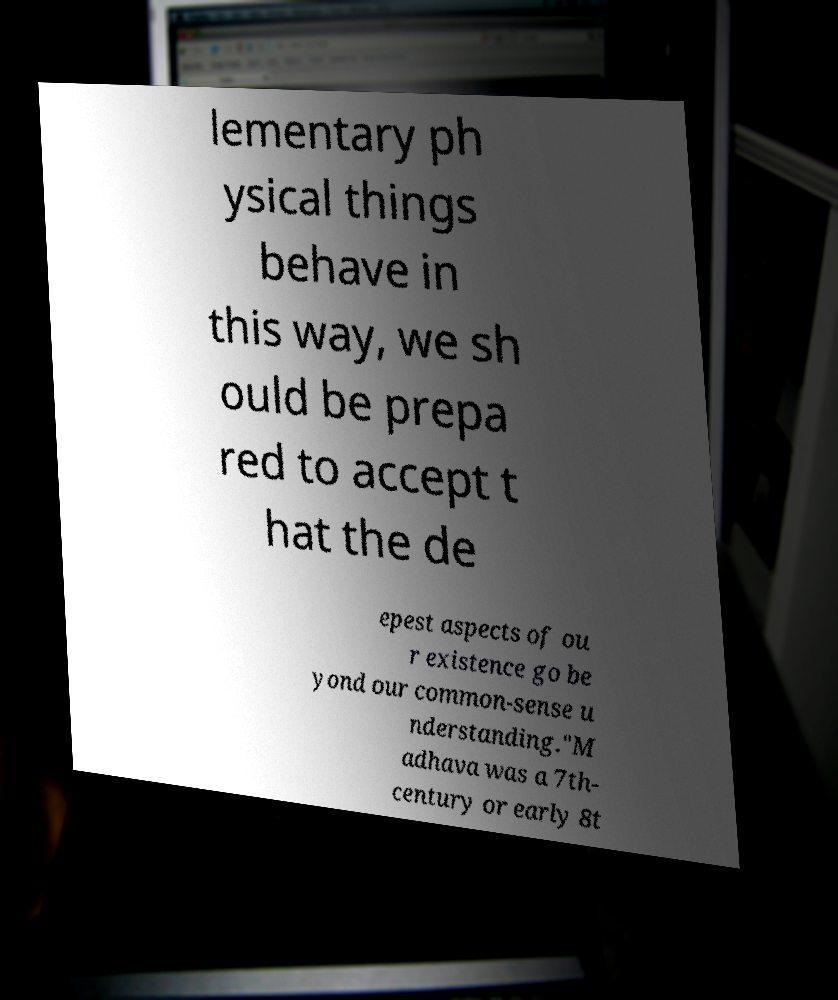Could you extract and type out the text from this image? lementary ph ysical things behave in this way, we sh ould be prepa red to accept t hat the de epest aspects of ou r existence go be yond our common-sense u nderstanding."M adhava was a 7th- century or early 8t 